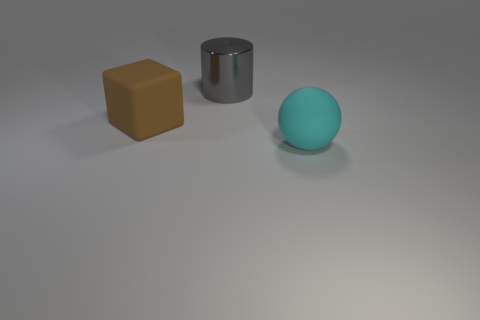Do the shiny object and the brown thing have the same size?
Your response must be concise. Yes. What number of cylinders are big gray objects or large brown matte things?
Offer a very short reply. 1. There is a big matte object on the right side of the big metallic object; what number of gray shiny objects are behind it?
Provide a succinct answer. 1. Does the big gray metallic object have the same shape as the cyan matte thing?
Provide a short and direct response. No. There is a matte thing that is to the right of the large matte thing on the left side of the gray thing; what shape is it?
Provide a succinct answer. Sphere. How big is the rubber sphere?
Provide a succinct answer. Large. What is the shape of the big brown rubber thing?
Offer a terse response. Cube. There is a large cyan rubber thing; is it the same shape as the matte object behind the cyan ball?
Offer a very short reply. No. Does the large matte object in front of the large brown thing have the same shape as the gray metallic object?
Provide a succinct answer. No. What number of things are behind the large brown matte cube and on the left side of the large gray cylinder?
Offer a terse response. 0. 